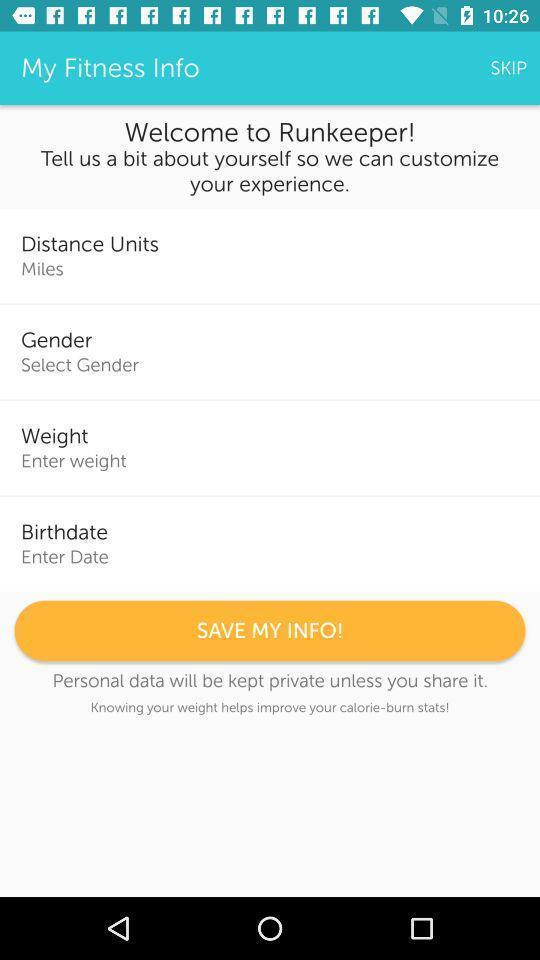Give me a narrative description of this picture. Welcome page with option. 